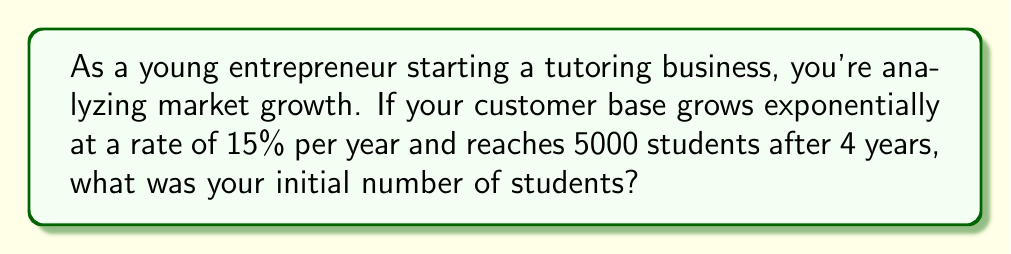Can you solve this math problem? Let's approach this step-by-step:

1) The formula for exponential growth is:
   $$P(t) = P_0 \cdot e^{rt}$$
   where:
   $P(t)$ is the population at time $t$
   $P_0$ is the initial population
   $r$ is the growth rate
   $t$ is the time

2) We know:
   $P(4) = 5000$ (final population after 4 years)
   $r = 0.15$ (15% annual growth rate)
   $t = 4$ years

3) Let's substitute these into our formula:
   $$5000 = P_0 \cdot e^{0.15 \cdot 4}$$

4) Simplify the exponent:
   $$5000 = P_0 \cdot e^{0.6}$$

5) To solve for $P_0$, divide both sides by $e^{0.6}$:
   $$P_0 = \frac{5000}{e^{0.6}}$$

6) Calculate $e^{0.6}$ (you can use a calculator):
   $$e^{0.6} \approx 1.8221$$

7) Now divide:
   $$P_0 = \frac{5000}{1.8221} \approx 2744.03$$

8) Since we're dealing with students, we need to round to the nearest whole number:
   $$P_0 \approx 2744 \text{ students}$$
Answer: 2744 students 